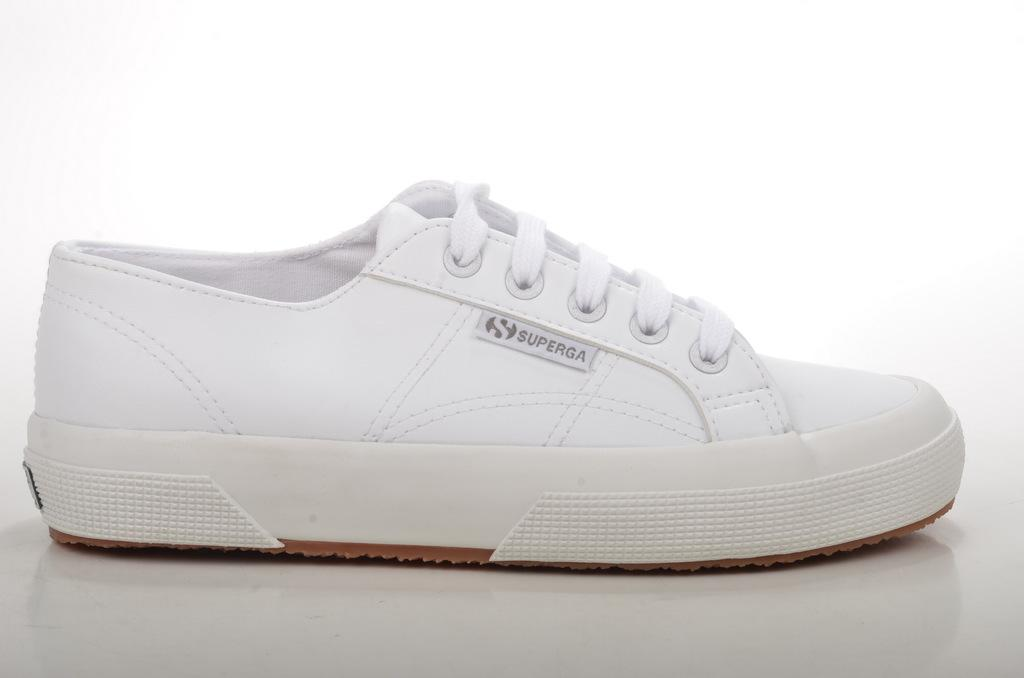What object is the main subject of the image? There is a shoe in the image. What colors can be seen on the shoe? The shoe is white and brown in color. What is the shoe placed on in the image? The shoe is on a white colored surface. What color dominates the background of the image? The background of the image is white. What type of bat can be seen flying in the image? There is no bat present in the image; it features a shoe on a white surface with a white background. What is the source of the surprise in the image? There is no surprise or any indication of a surprise in the image. 